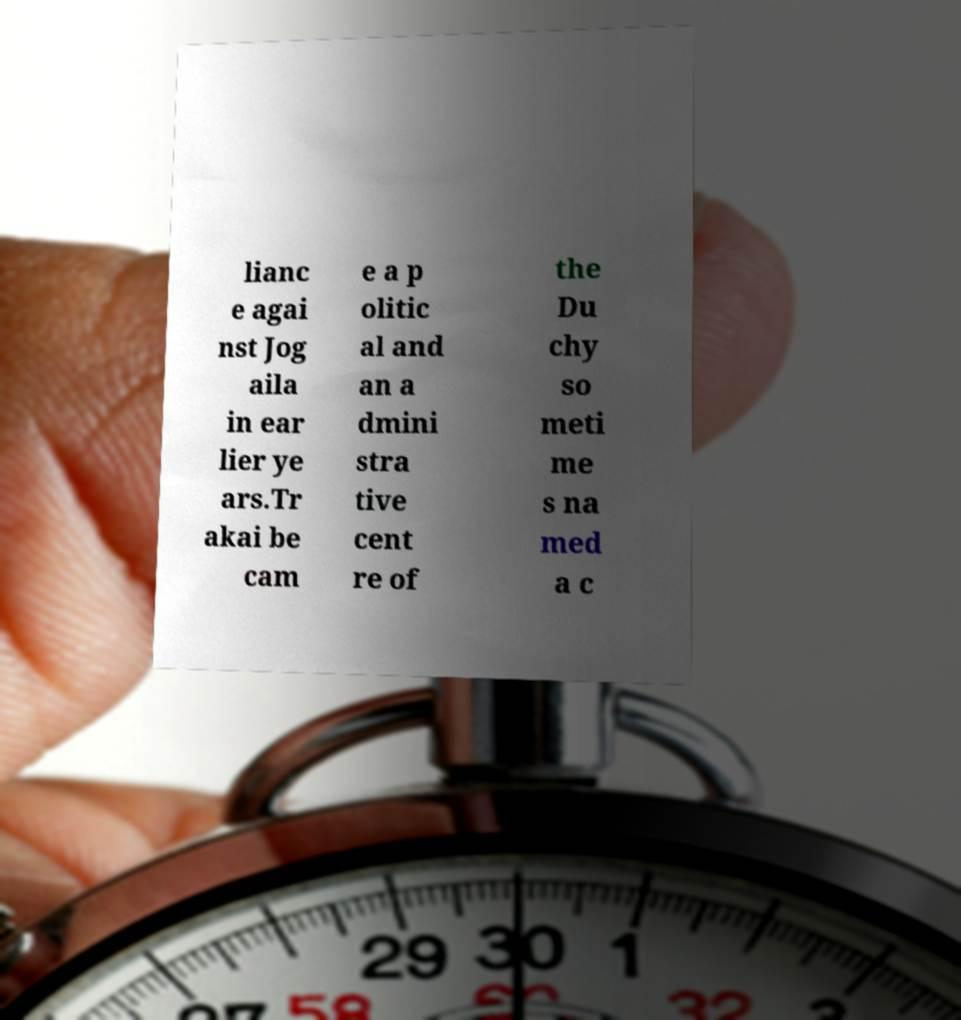Could you assist in decoding the text presented in this image and type it out clearly? lianc e agai nst Jog aila in ear lier ye ars.Tr akai be cam e a p olitic al and an a dmini stra tive cent re of the Du chy so meti me s na med a c 